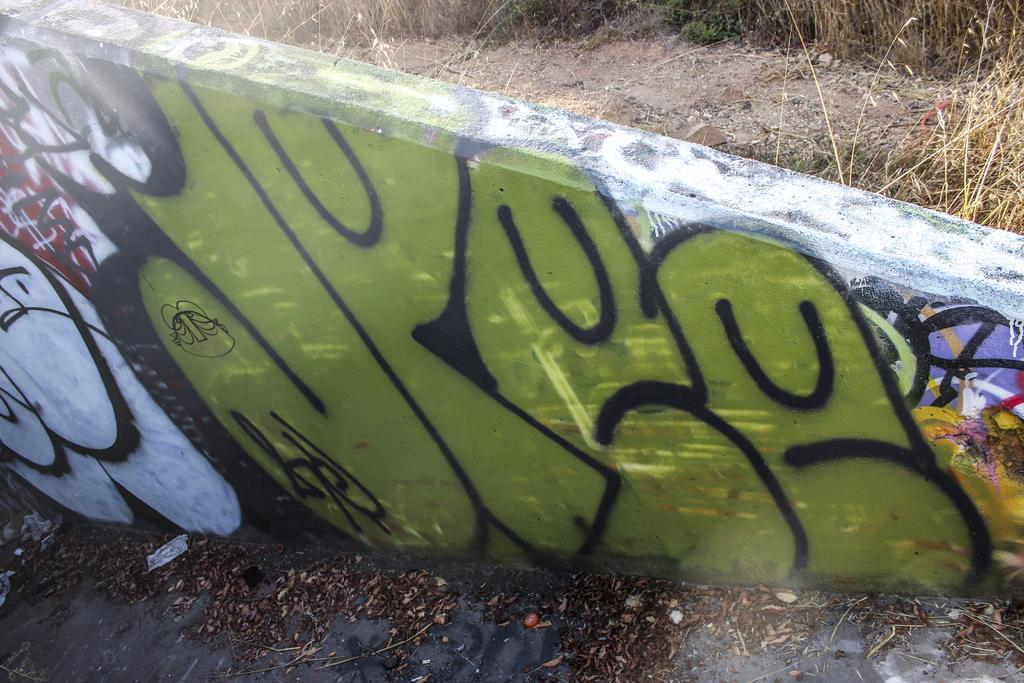What is the main subject in the center of the image? There is a painting on a wall in the center of the image. What type of environment is depicted in the background of the image? The background of the image features dry grass. What type of terrain is visible in the image? There is sand visible in the image. What type of vegetation is present at the bottom side of the image? There are dry leaves at the bottom side of the image. What level of shame does the painting express in the image? The painting does not express any level of shame, as it is an inanimate object and cannot experience emotions. 